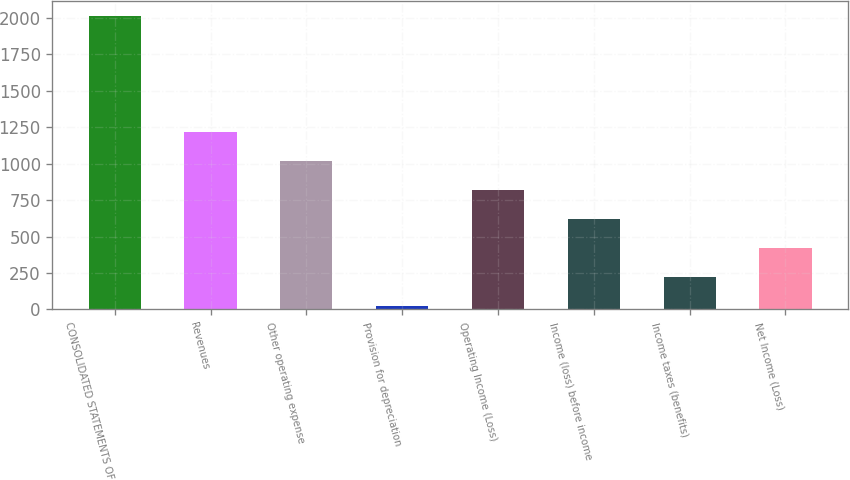Convert chart to OTSL. <chart><loc_0><loc_0><loc_500><loc_500><bar_chart><fcel>CONSOLIDATED STATEMENTS OF<fcel>Revenues<fcel>Other operating expense<fcel>Provision for depreciation<fcel>Operating Income (Loss)<fcel>Income (loss) before income<fcel>Income taxes (benefits)<fcel>Net Income (Loss)<nl><fcel>2011<fcel>1215.8<fcel>1017<fcel>23<fcel>818.2<fcel>619.4<fcel>221.8<fcel>420.6<nl></chart> 